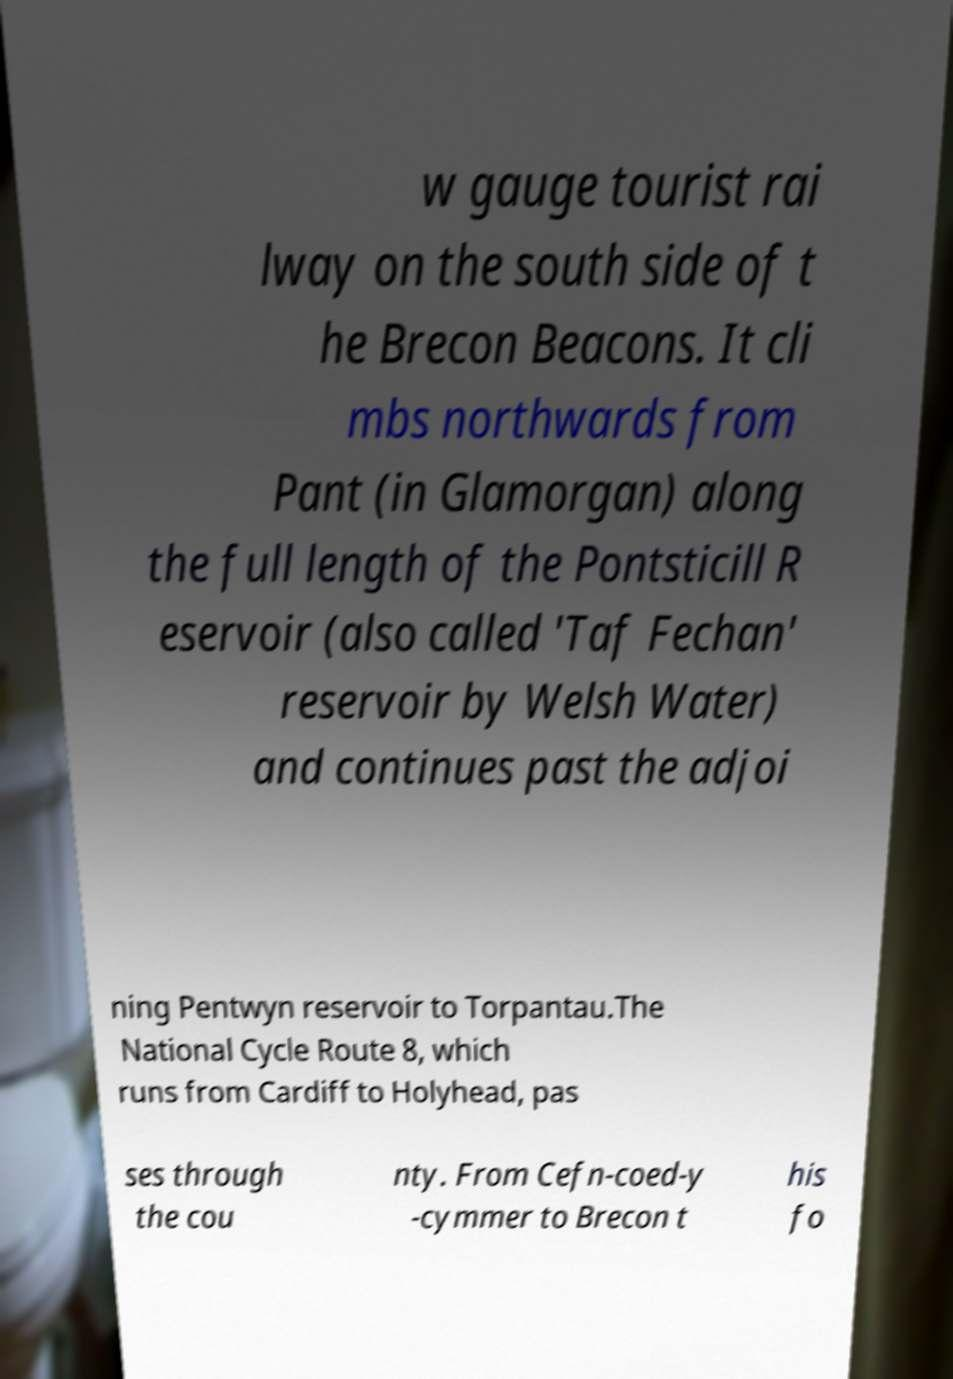For documentation purposes, I need the text within this image transcribed. Could you provide that? w gauge tourist rai lway on the south side of t he Brecon Beacons. It cli mbs northwards from Pant (in Glamorgan) along the full length of the Pontsticill R eservoir (also called 'Taf Fechan' reservoir by Welsh Water) and continues past the adjoi ning Pentwyn reservoir to Torpantau.The National Cycle Route 8, which runs from Cardiff to Holyhead, pas ses through the cou nty. From Cefn-coed-y -cymmer to Brecon t his fo 